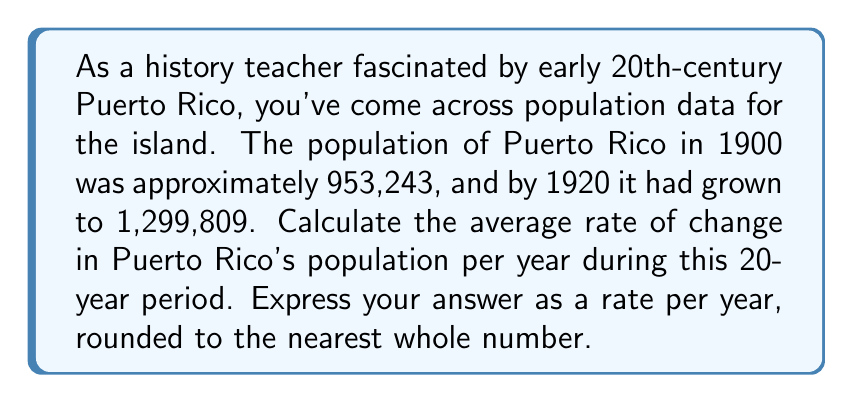Show me your answer to this math problem. To solve this problem, we need to use the average rate of change formula:

$$ \text{Average rate of change} = \frac{\text{Change in quantity}}{\text{Change in time}} $$

Let's break it down step by step:

1) First, let's identify our variables:
   Initial population (1900): $P_1 = 953,243$
   Final population (1920): $P_2 = 1,299,809$
   Time interval: $t = 20$ years

2) Calculate the total change in population:
   $\Delta P = P_2 - P_1 = 1,299,809 - 953,243 = 346,566$

3) Now, let's apply the average rate of change formula:

   $$ \text{Average rate of change} = \frac{\Delta P}{t} = \frac{346,566}{20} = 17,328.3 $$

4) Rounding to the nearest whole number:
   17,328.3 ≈ 17,328

This result represents the average number of people added to Puerto Rico's population each year between 1900 and 1920.
Answer: The average rate of change in Puerto Rico's population from 1900 to 1920 was approximately 17,328 people per year. 